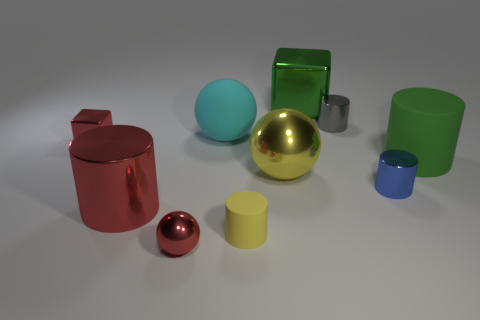What is the color of the tiny cylinder that is made of the same material as the large cyan sphere?
Keep it short and to the point. Yellow. Are there more tiny red metallic spheres that are right of the yellow ball than large cyan spheres left of the large red cylinder?
Keep it short and to the point. No. Is there a large rubber cylinder?
Give a very brief answer. Yes. There is a large cylinder that is the same color as the tiny metal block; what material is it?
Provide a succinct answer. Metal. What number of things are either tiny yellow matte things or metal things?
Give a very brief answer. 8. Is there a big metal cylinder that has the same color as the small metal sphere?
Offer a very short reply. Yes. What number of large metal things are in front of the metallic cube to the right of the small shiny sphere?
Offer a terse response. 2. Is the number of green matte balls greater than the number of small yellow rubber objects?
Ensure brevity in your answer.  No. Does the large yellow ball have the same material as the tiny yellow object?
Offer a terse response. No. Are there the same number of gray metal cylinders that are in front of the small yellow cylinder and tiny blue cylinders?
Keep it short and to the point. No. 